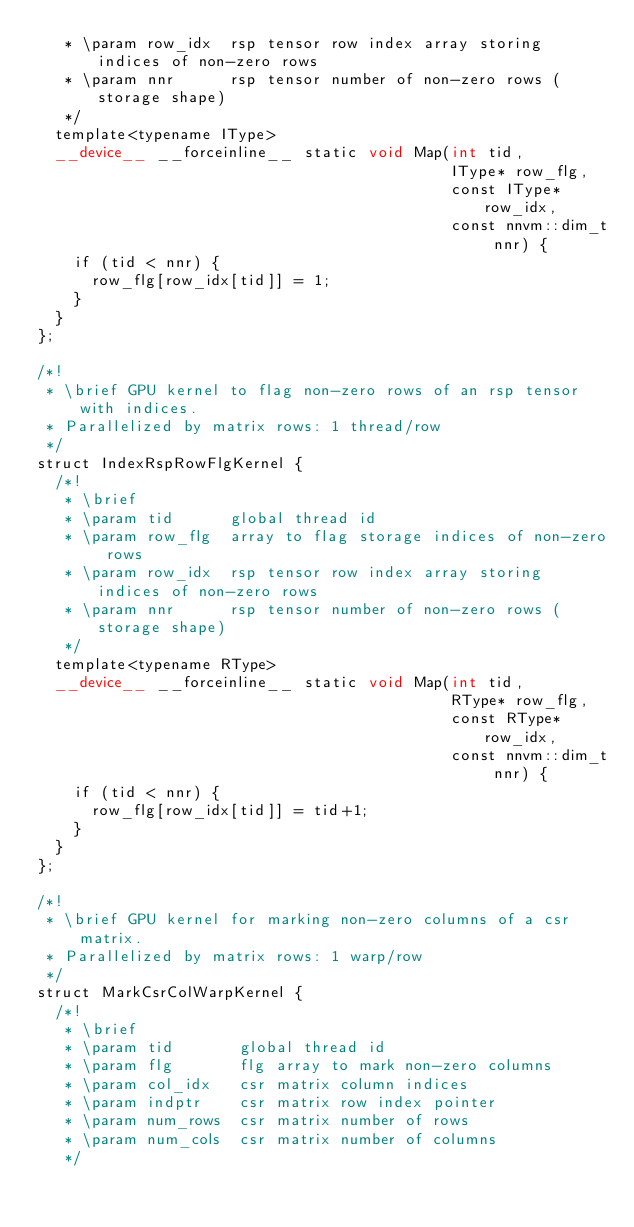Convert code to text. <code><loc_0><loc_0><loc_500><loc_500><_Cuda_>   * \param row_idx  rsp tensor row index array storing indices of non-zero rows
   * \param nnr      rsp tensor number of non-zero rows (storage shape)
   */
  template<typename IType>
  __device__ __forceinline__ static void Map(int tid,
                                             IType* row_flg,
                                             const IType* row_idx,
                                             const nnvm::dim_t nnr) {
    if (tid < nnr) {
      row_flg[row_idx[tid]] = 1;
    }
  }
};

/*!
 * \brief GPU kernel to flag non-zero rows of an rsp tensor with indices.
 * Parallelized by matrix rows: 1 thread/row
 */
struct IndexRspRowFlgKernel {
  /*!
   * \brief
   * \param tid      global thread id
   * \param row_flg  array to flag storage indices of non-zero rows
   * \param row_idx  rsp tensor row index array storing indices of non-zero rows
   * \param nnr      rsp tensor number of non-zero rows (storage shape)
   */
  template<typename RType>
  __device__ __forceinline__ static void Map(int tid,
                                             RType* row_flg,
                                             const RType* row_idx,
                                             const nnvm::dim_t nnr) {
    if (tid < nnr) {
      row_flg[row_idx[tid]] = tid+1;
    }
  }
};

/*!
 * \brief GPU kernel for marking non-zero columns of a csr matrix.
 * Parallelized by matrix rows: 1 warp/row
 */
struct MarkCsrColWarpKernel {
  /*!
   * \brief
   * \param tid       global thread id
   * \param flg       flg array to mark non-zero columns
   * \param col_idx   csr matrix column indices
   * \param indptr    csr matrix row index pointer
   * \param num_rows  csr matrix number of rows
   * \param num_cols  csr matrix number of columns
   */</code> 